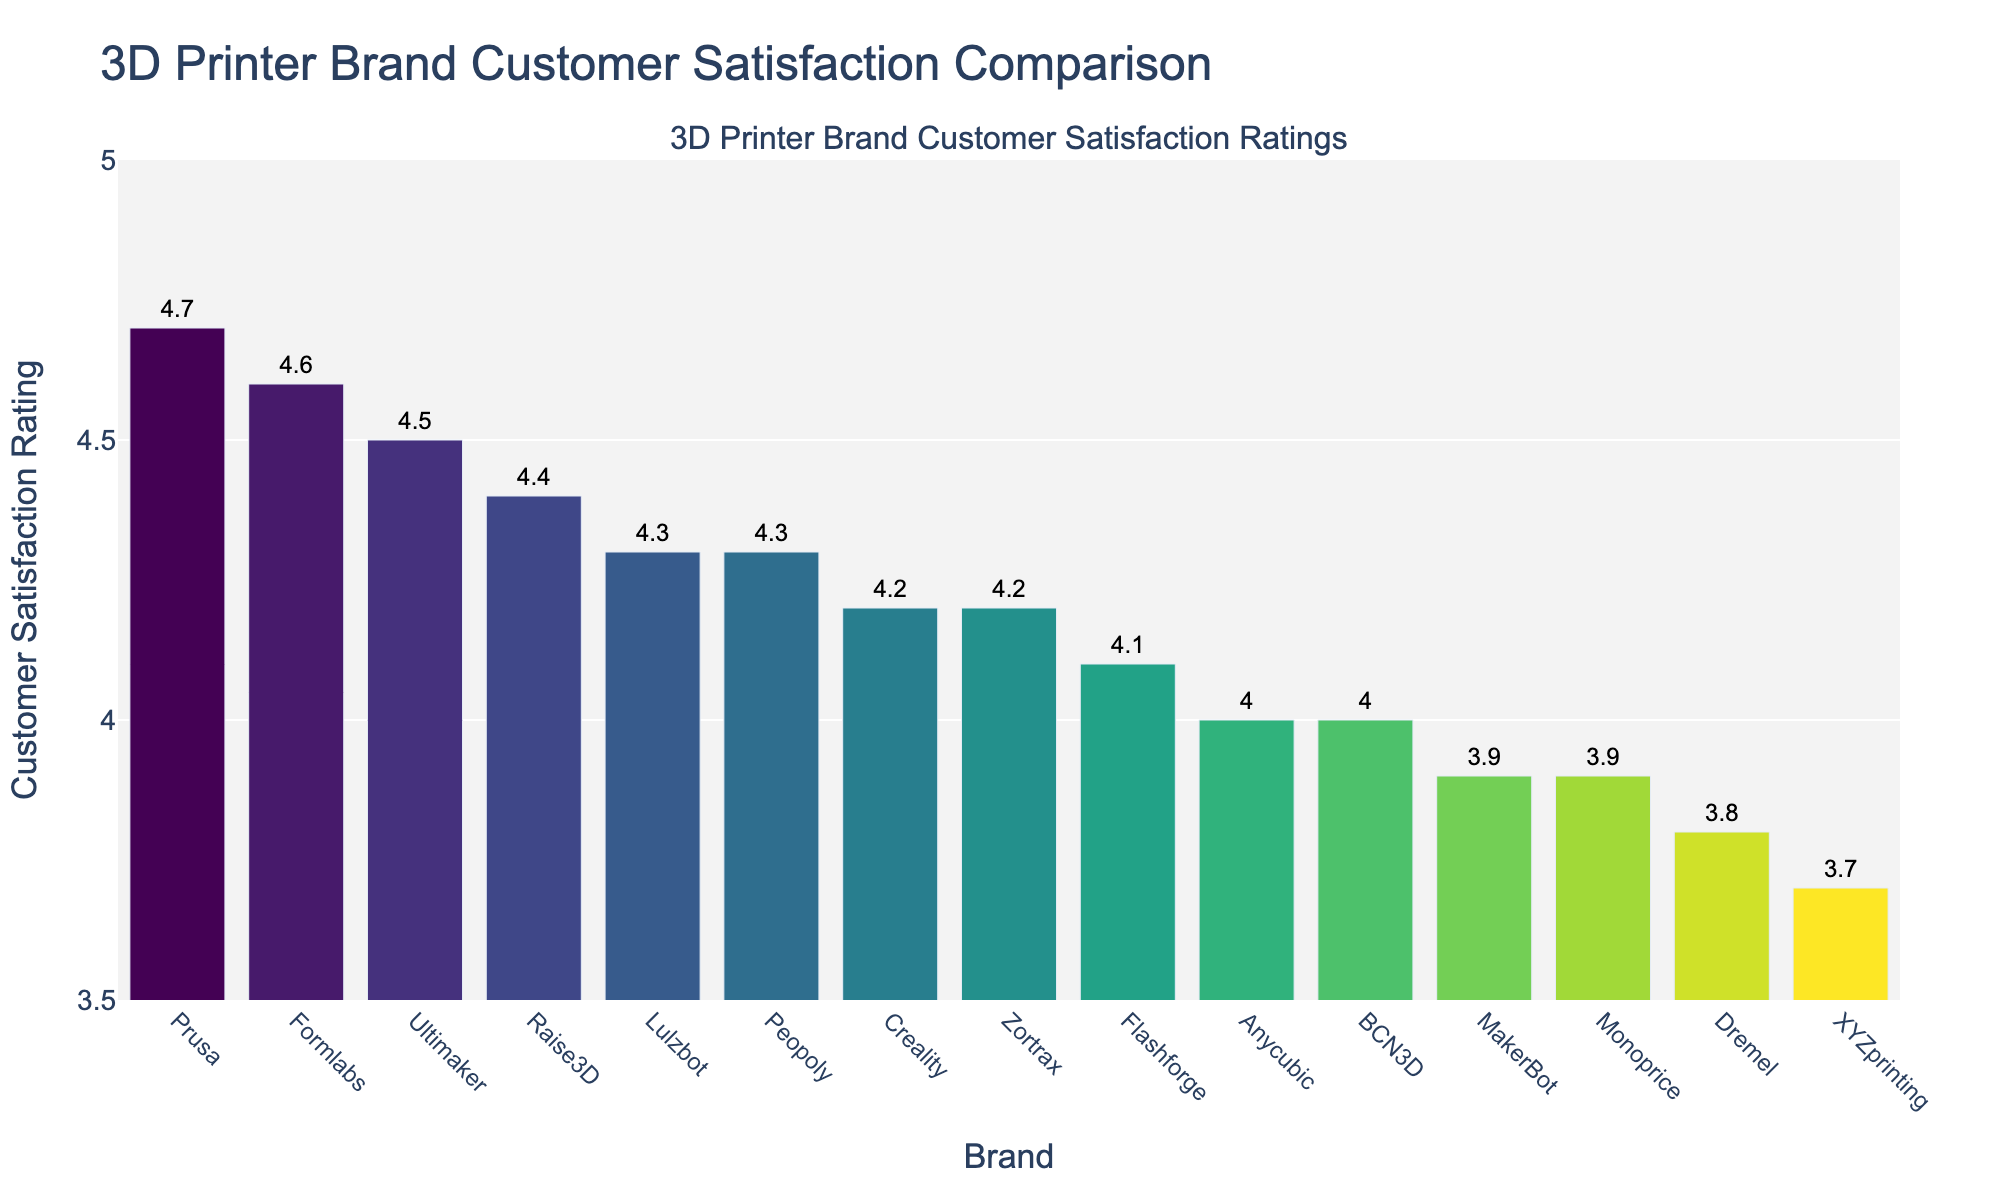Which brand has the highest customer satisfaction rating? The figure shows the customer satisfaction ratings for different 3D printer brands. By examining the height of the bars, Prusa has the highest rating at 4.7.
Answer: Prusa Which two brands have the same customer satisfaction rating? To identify brands with the same ratings, compare the heights of the bars. Creality and Zortrax both have a rating of 4.2.
Answer: Creality and Zortrax What is the average customer satisfaction rating of all brands? Add up all the customer satisfaction ratings from the figure and divide by the total number of brands. The sum is (4.7 + 4.2 + 4.5 + 4.0 + 4.6 + 3.9 + 4.1 + 4.3 + 4.2 + 4.0 + 4.4 + 3.8 + 3.7 + 3.9 + 4.3) = 62.6, and there are 15 brands. The average rating is 62.6 / 15 = 4.17.
Answer: 4.17 Which brand has a rating just below Prusa? By looking at the bar heights, Formlabs has a rating of 4.6, which is just below Prusa's 4.7.
Answer: Formlabs What is the difference in customer satisfaction ratings between the highest and lowest rated brands? The highest rating is Prusa with 4.7, and the lowest rating is XYZprinting with 3.7. The difference is 4.7 - 3.7 = 1.0.
Answer: 1.0 How many brands have a rating equal to or above 4.5? Count the number of bars with ratings of 4.5 and above. Prusa (4.7), Formlabs (4.6), Ultimaker (4.5), and Raise3D (4.4) are 4 brands.
Answer: 4 Which brand has the median customer satisfaction rating? To find the median, list all the ratings in increasing order and locate the middle value. The sorted ratings are: 3.7, 3.8, 3.9, 3.9, 4.0, 4.0, 4.1, 4.2, 4.2, 4.3, 4.3, 4.4, 4.5, 4.6, 4.7. The median is the 8th value, which is 4.2 (Zortrax or Creality).
Answer: Zortrax or Creality Which brands have ratings below the average rating? First, calculate the average rating (4.17). Then, identify brands with ratings below this average: Anycubic (4.0), MakerBot (3.9), Flashforge (4.1), Dremel (3.8), XYZprinting (3.7), and Monoprice (3.9).
Answer: Anycubic, MakerBot, Flashforge, Dremel, XYZprinting, Monoprice 